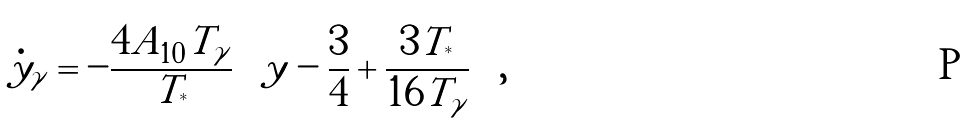Convert formula to latex. <formula><loc_0><loc_0><loc_500><loc_500>\dot { y } _ { \gamma } = - \frac { 4 A _ { 1 0 } T _ { \gamma } } { T _ { ^ { * } } } \left ( y - \frac { 3 } { 4 } + \frac { 3 T _ { ^ { * } } } { 1 6 T _ { \gamma } } \right ) ,</formula> 